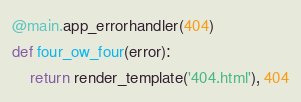Convert code to text. <code><loc_0><loc_0><loc_500><loc_500><_Python_>
@main.app_errorhandler(404)
def four_ow_four(error):
    return render_template('404.html'), 404</code> 